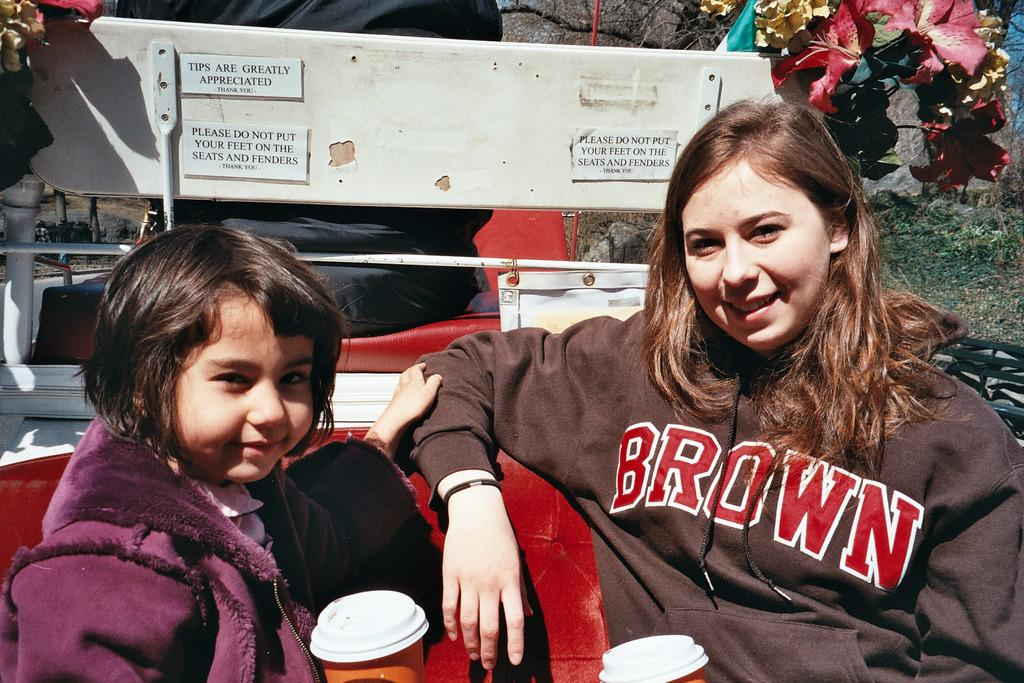<image>
Share a concise interpretation of the image provided. A girl in a Brown sweatshirt sits next to a younger girl. 